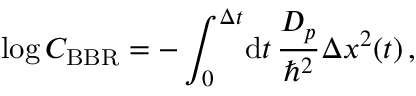Convert formula to latex. <formula><loc_0><loc_0><loc_500><loc_500>\log C _ { B B R } = - \int _ { 0 } ^ { \Delta t } \, d t \, \frac { D _ { p } } { \hbar { ^ } { 2 } } \Delta x ^ { 2 } ( t ) \, ,</formula> 